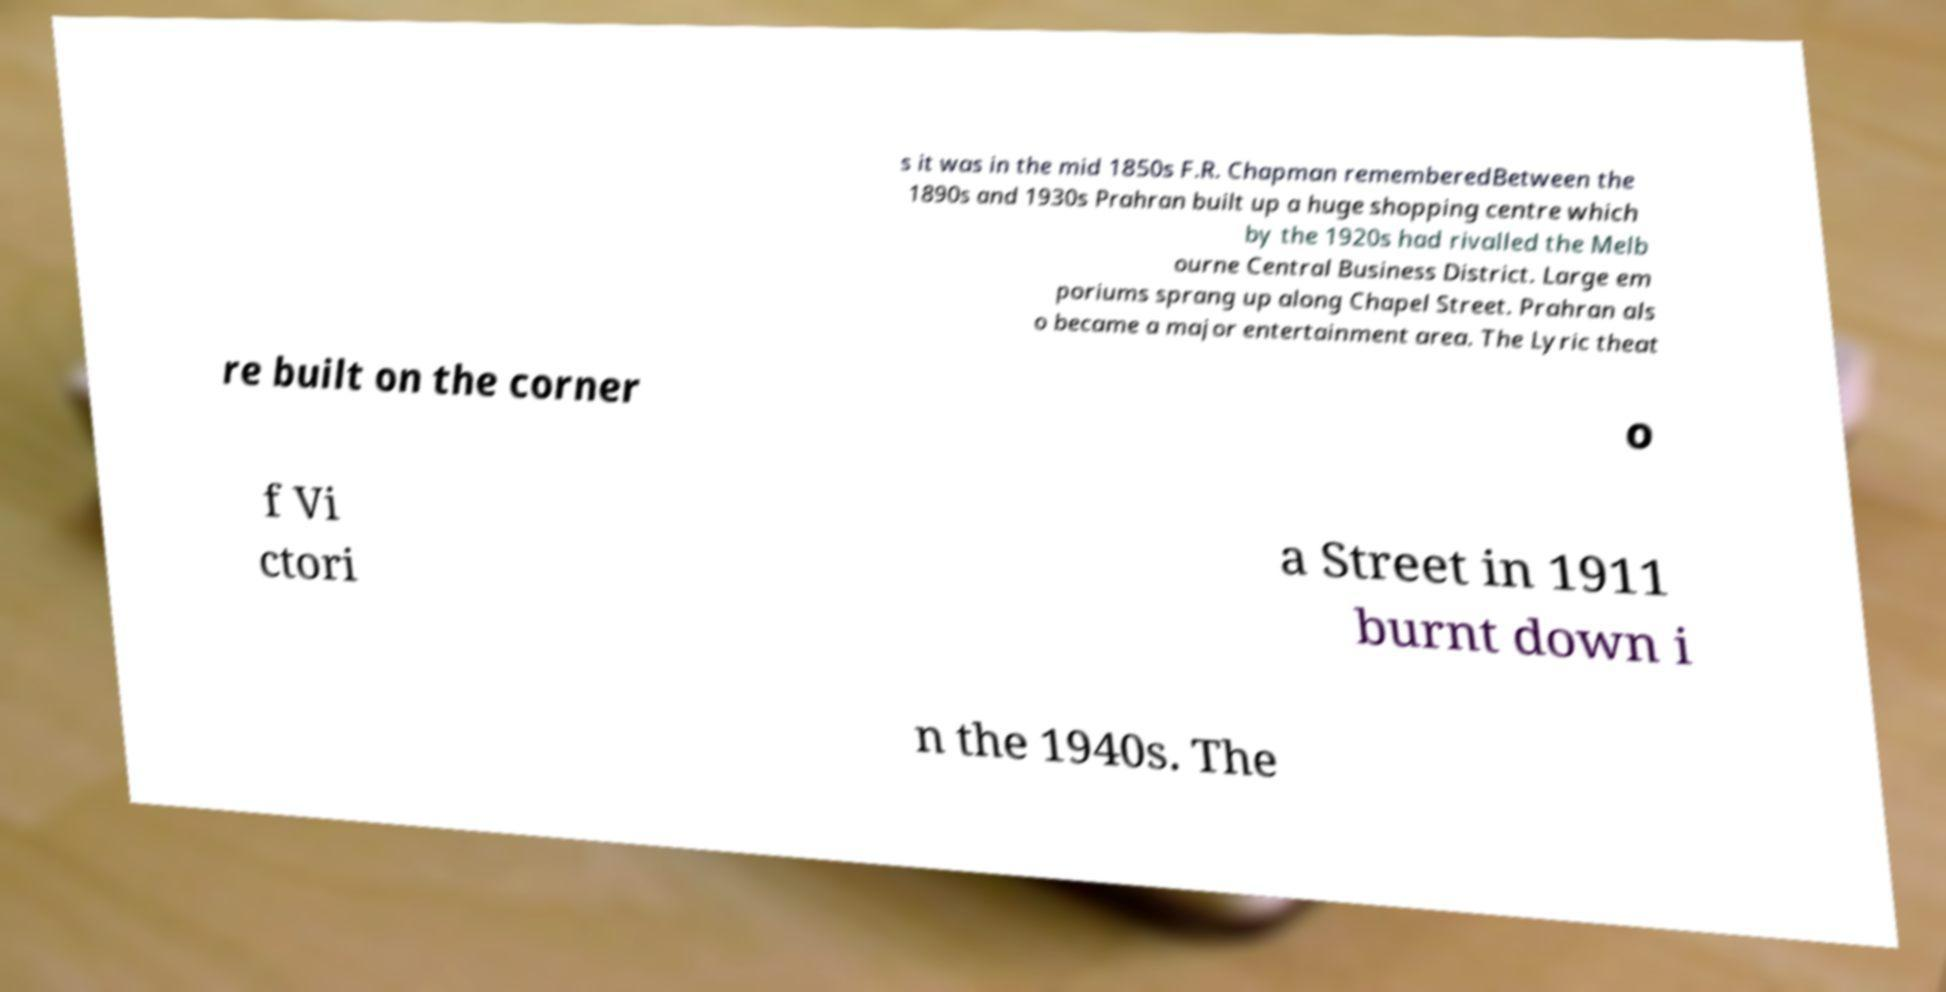Can you accurately transcribe the text from the provided image for me? s it was in the mid 1850s F.R. Chapman rememberedBetween the 1890s and 1930s Prahran built up a huge shopping centre which by the 1920s had rivalled the Melb ourne Central Business District. Large em poriums sprang up along Chapel Street. Prahran als o became a major entertainment area. The Lyric theat re built on the corner o f Vi ctori a Street in 1911 burnt down i n the 1940s. The 